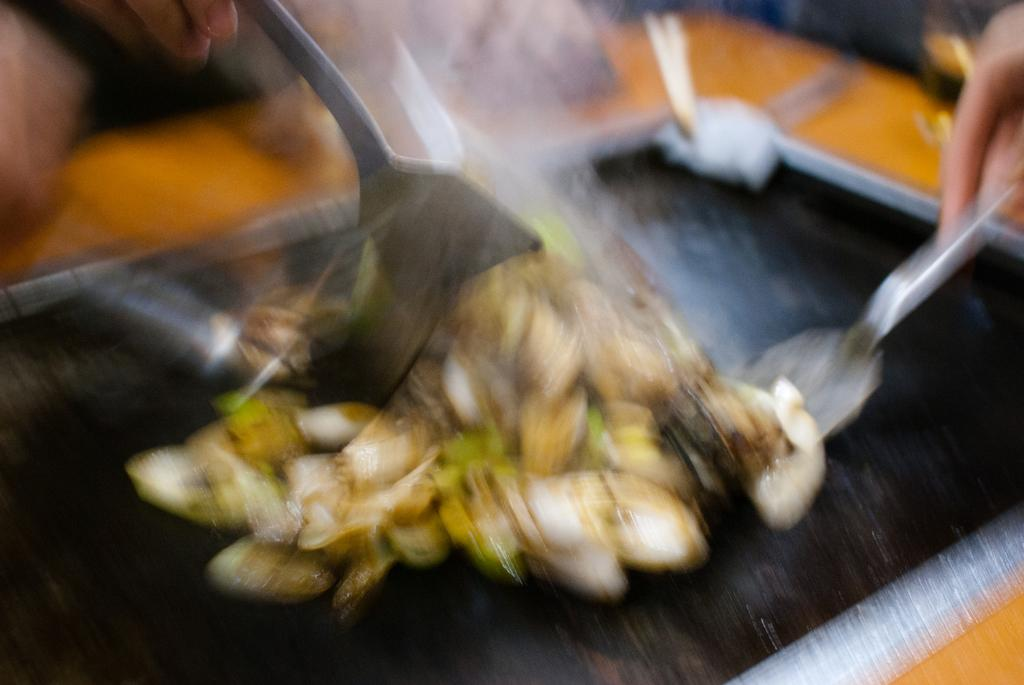What is the overall quality of the image? The image appears to be blurry. Can you accurately describe the food item in the image due to its blurry nature? No, due to the blurry nature of the image, we cannot accurately describe the food item in the image. What is the position of the tiger in the image? There is no tiger present in the image. How many coils can be seen in the image? Since we cannot accurately describe the food item in the image due to its blurry nature, we cannot determine the number of coils present. 